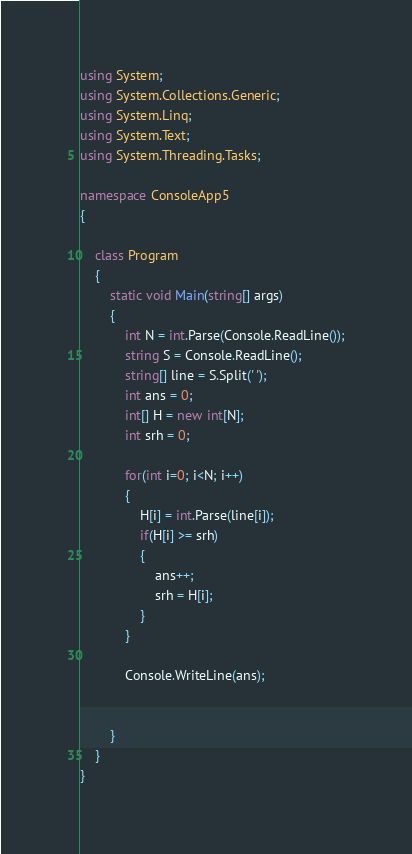Convert code to text. <code><loc_0><loc_0><loc_500><loc_500><_C#_>using System;
using System.Collections.Generic;
using System.Linq;
using System.Text;
using System.Threading.Tasks;

namespace ConsoleApp5
{

    class Program
    {
        static void Main(string[] args)
        {
            int N = int.Parse(Console.ReadLine());
            string S = Console.ReadLine();
            string[] line = S.Split(' ');
            int ans = 0;
            int[] H = new int[N];
            int srh = 0;

            for(int i=0; i<N; i++)
            {
                H[i] = int.Parse(line[i]);
                if(H[i] >= srh)
                {
                    ans++;
                    srh = H[i];
                }
            }
            
            Console.WriteLine(ans);


        }
    }
}</code> 